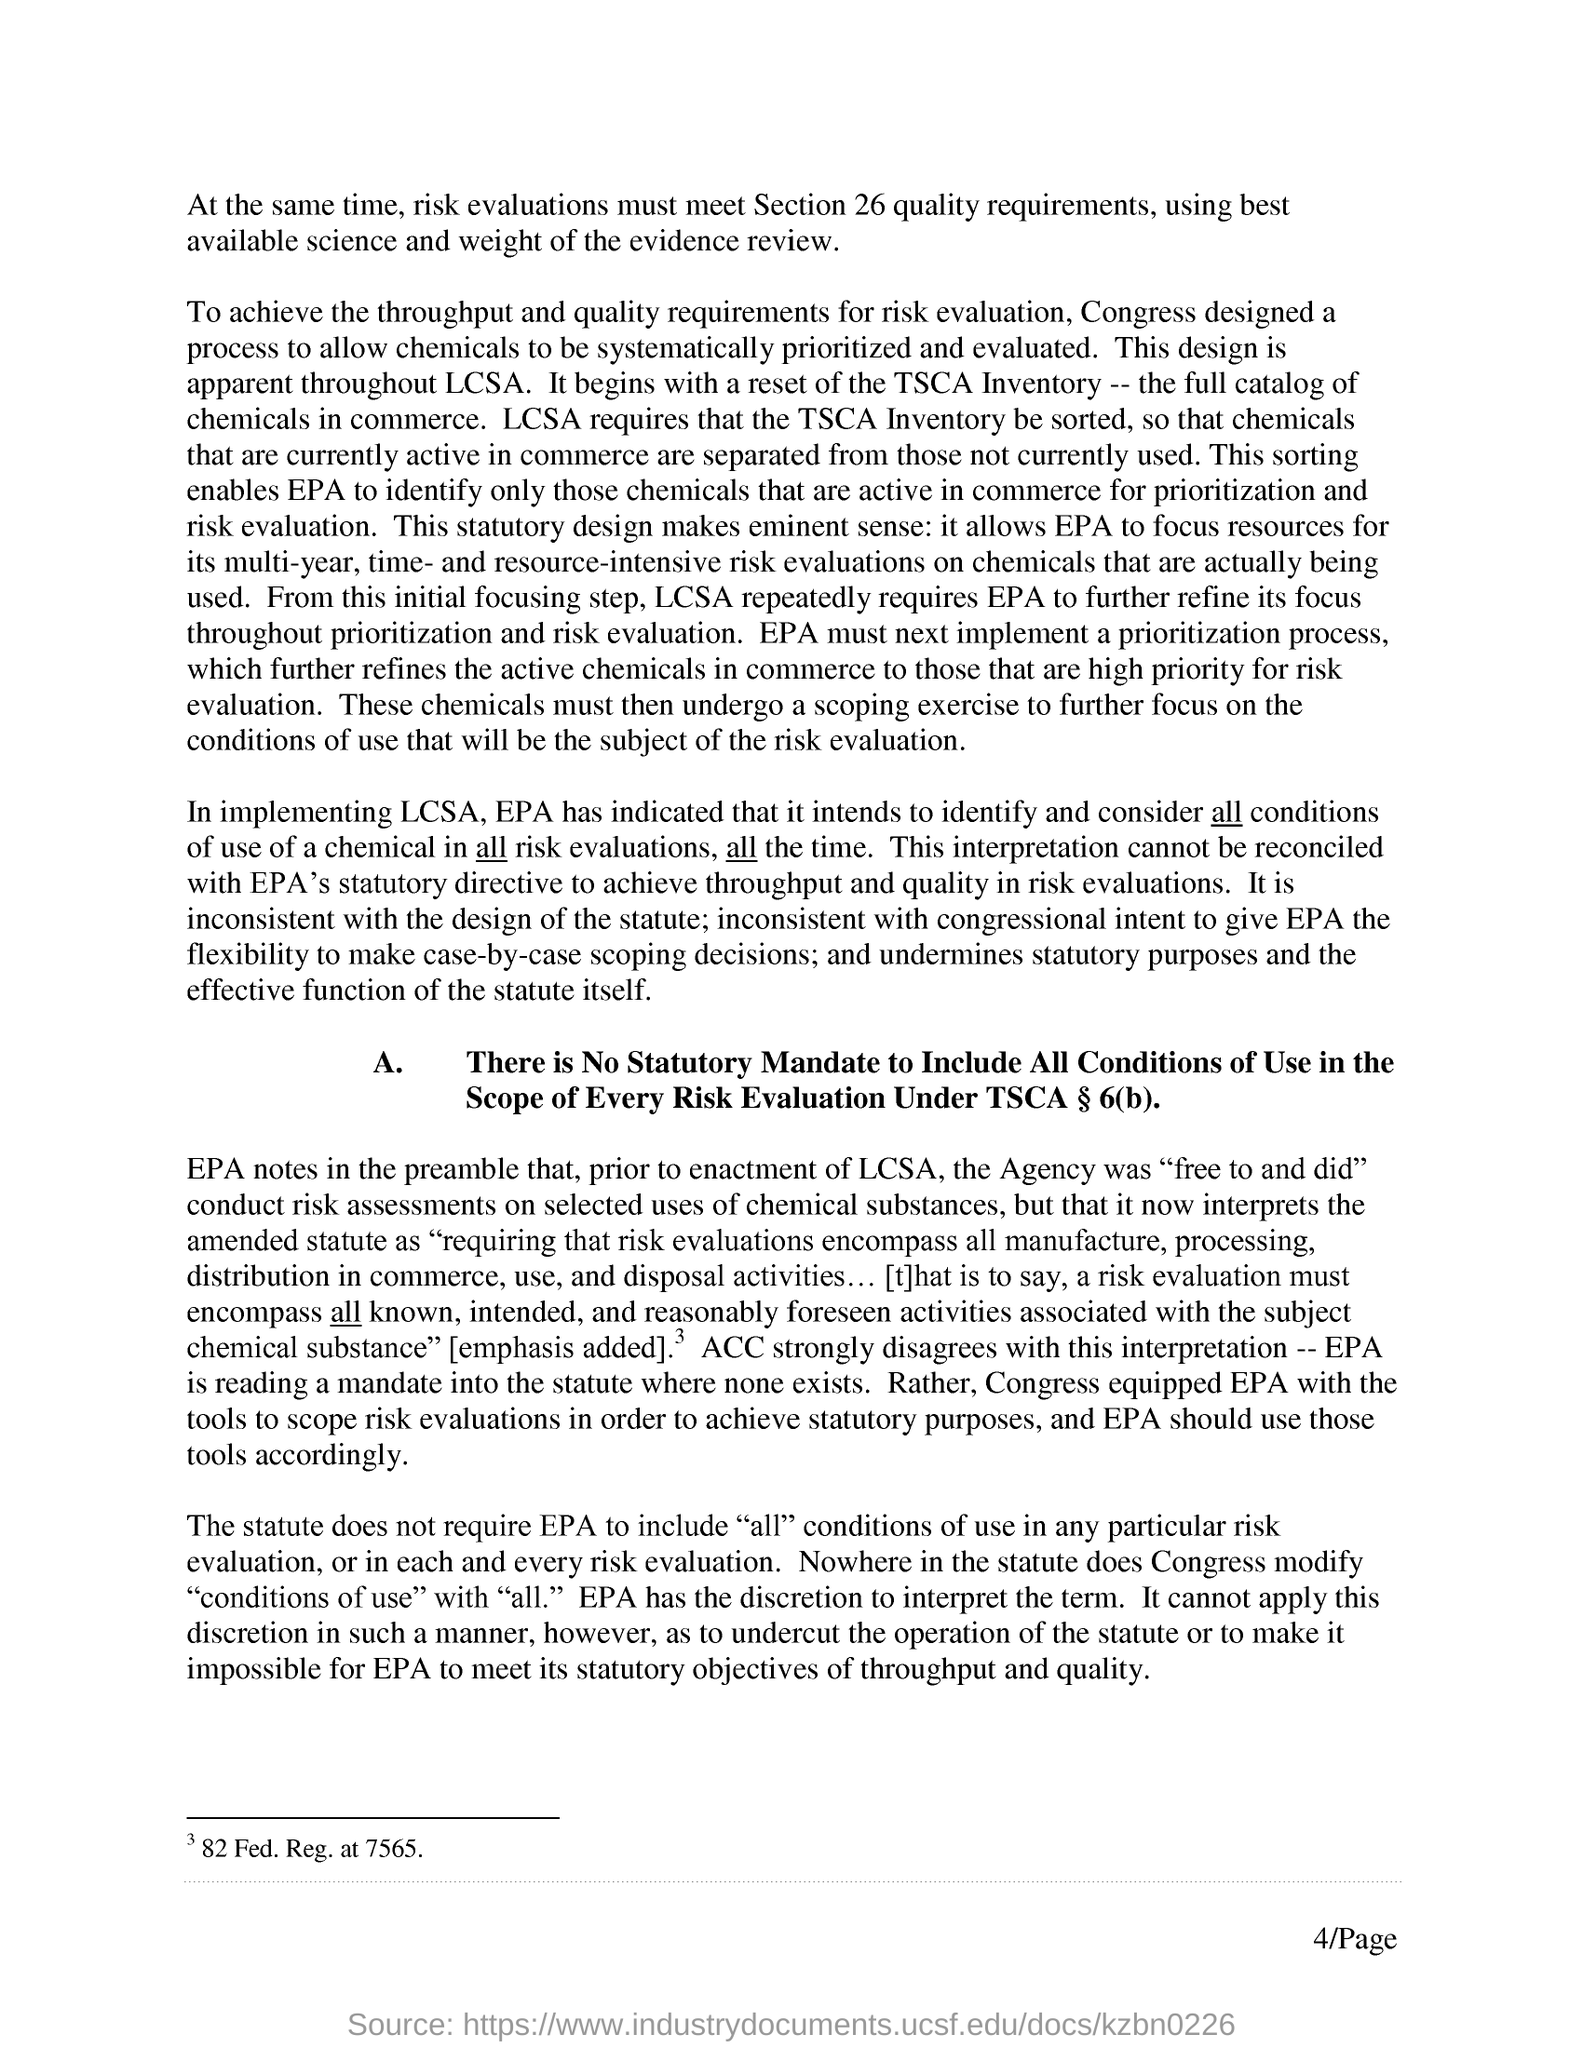What is the Page Number?
Your response must be concise. 4/PAGE. 